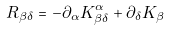<formula> <loc_0><loc_0><loc_500><loc_500>R _ { \beta \delta } = - \partial _ { \alpha } K ^ { \alpha } _ { \beta \delta } + \partial _ { \delta } K _ { \beta }</formula> 